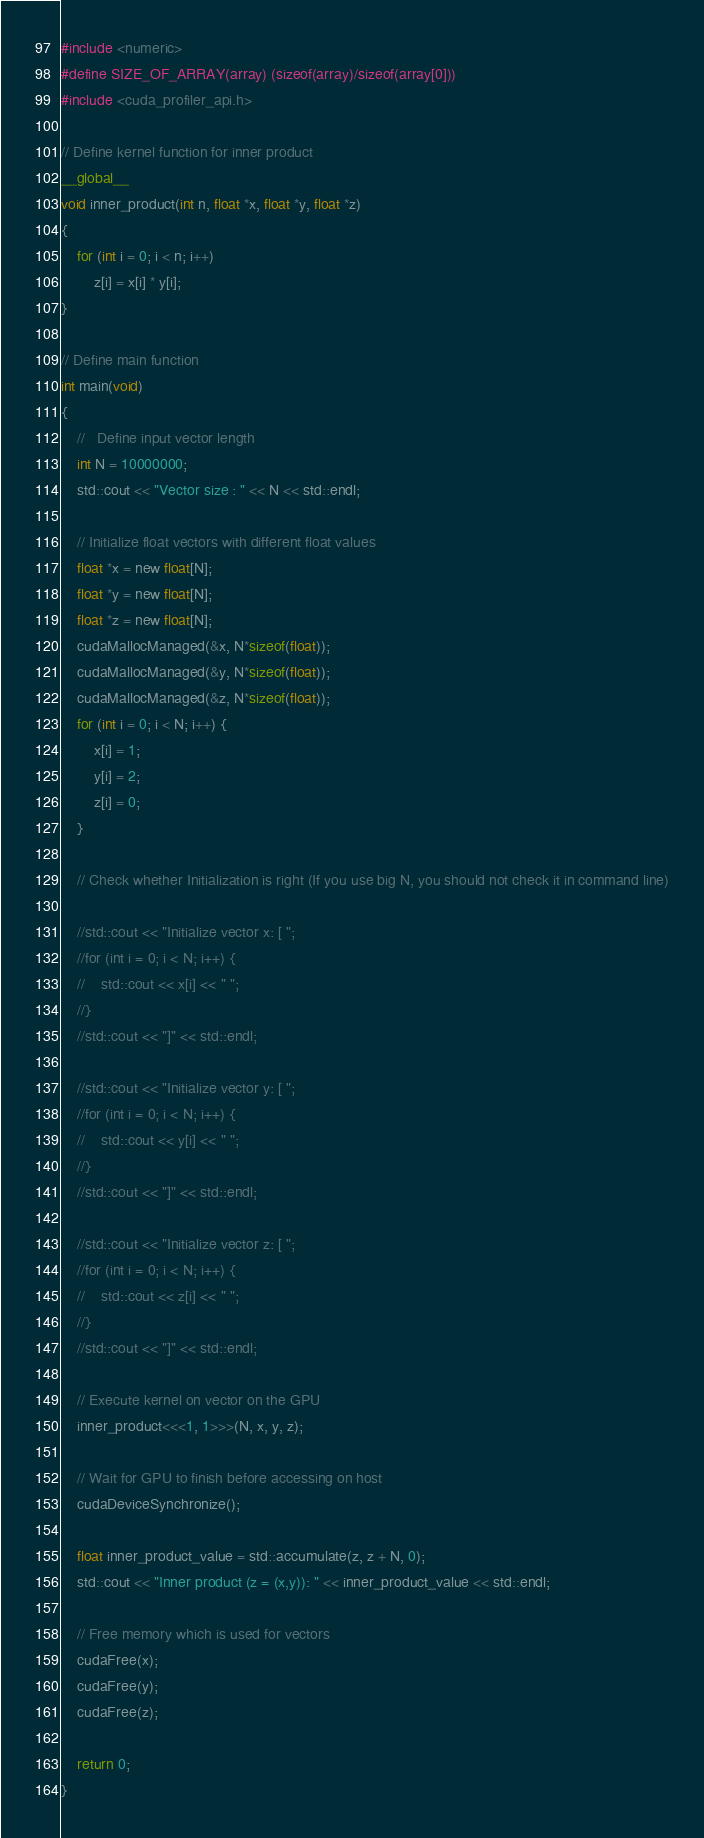Convert code to text. <code><loc_0><loc_0><loc_500><loc_500><_Cuda_>#include <numeric>
#define SIZE_OF_ARRAY(array) (sizeof(array)/sizeof(array[0]))
#include <cuda_profiler_api.h>

// Define kernel function for inner product
__global__
void inner_product(int n, float *x, float *y, float *z)
{
    for (int i = 0; i < n; i++)
        z[i] = x[i] * y[i];
}

// Define main function
int main(void)
{
    //   Define input vector length
    int N = 10000000;
    std::cout << "Vector size : " << N << std::endl;  
   
    // Initialize float vectors with different float values
    float *x = new float[N];
    float *y = new float[N];
    float *z = new float[N];
    cudaMallocManaged(&x, N*sizeof(float));
    cudaMallocManaged(&y, N*sizeof(float));
    cudaMallocManaged(&z, N*sizeof(float));
    for (int i = 0; i < N; i++) {
        x[i] = 1;
        y[i] = 2;
        z[i] = 0;
    }

    // Check whether Initialization is right (If you use big N, you should not check it in command line)

    //std::cout << "Initialize vector x: [ ";
    //for (int i = 0; i < N; i++) {
    //    std::cout << x[i] << " ";
    //}
    //std::cout << "]" << std::endl;

    //std::cout << "Initialize vector y: [ ";
    //for (int i = 0; i < N; i++) {
    //    std::cout << y[i] << " ";
    //}
    //std::cout << "]" << std::endl;

    //std::cout << "Initialize vector z: [ ";
    //for (int i = 0; i < N; i++) {
    //    std::cout << z[i] << " ";
    //}
    //std::cout << "]" << std::endl;

    // Execute kernel on vector on the GPU
    inner_product<<<1, 1>>>(N, x, y, z);

    // Wait for GPU to finish before accessing on host
    cudaDeviceSynchronize();

    float inner_product_value = std::accumulate(z, z + N, 0);
    std::cout << "Inner product (z = (x,y)): " << inner_product_value << std::endl;
    
    // Free memory which is used for vectors
    cudaFree(x);
    cudaFree(y);
    cudaFree(z);
    
    return 0;
}</code> 